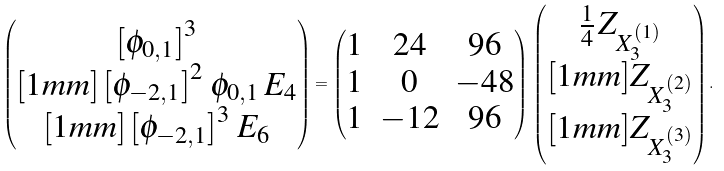Convert formula to latex. <formula><loc_0><loc_0><loc_500><loc_500>\begin{pmatrix} \left [ \phi _ { 0 , 1 } \right ] ^ { 3 } \\ [ 1 m m ] \left [ \phi _ { - 2 , 1 } \right ] ^ { 2 } \, \phi _ { 0 , 1 } \, E _ { 4 } \\ [ 1 m m ] \left [ \phi _ { - 2 , 1 } \right ] ^ { 3 } \, E _ { 6 } \end{pmatrix} = \begin{pmatrix} 1 & 2 4 & 9 6 \\ 1 & 0 & - 4 8 \\ 1 & - 1 2 & 9 6 \end{pmatrix} \, \begin{pmatrix} \frac { 1 } { 4 } \, Z _ { X _ { 3 } ^ { ( 1 ) } } \\ [ 1 m m ] Z _ { X _ { 3 } ^ { ( 2 ) } } \\ [ 1 m m ] Z _ { X _ { 3 } ^ { ( 3 ) } } \end{pmatrix} .</formula> 